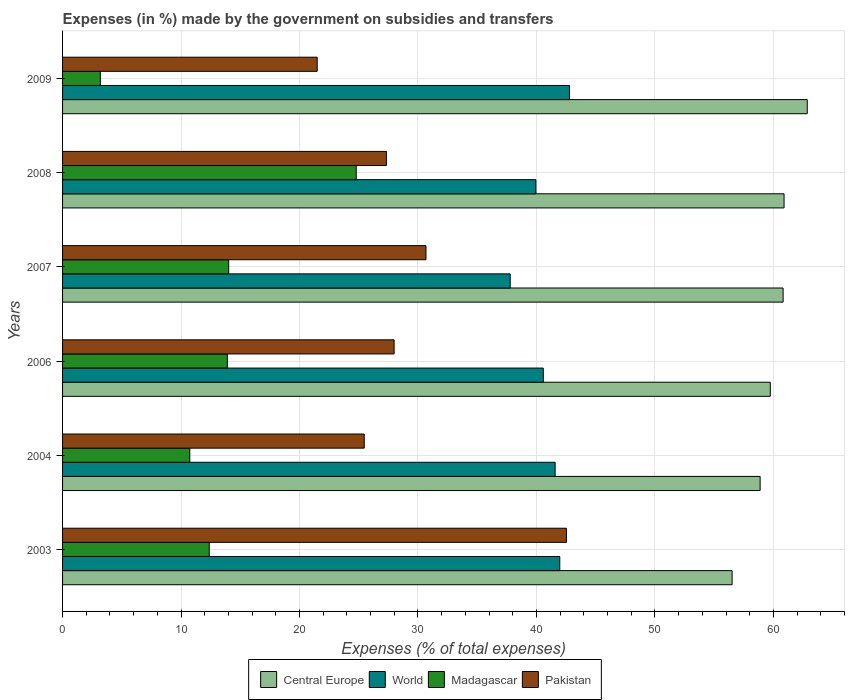How many groups of bars are there?
Your answer should be compact. 6. Are the number of bars per tick equal to the number of legend labels?
Your answer should be very brief. Yes. Are the number of bars on each tick of the Y-axis equal?
Your response must be concise. Yes. How many bars are there on the 2nd tick from the top?
Your answer should be compact. 4. How many bars are there on the 3rd tick from the bottom?
Ensure brevity in your answer.  4. In how many cases, is the number of bars for a given year not equal to the number of legend labels?
Your response must be concise. 0. What is the percentage of expenses made by the government on subsidies and transfers in Pakistan in 2003?
Make the answer very short. 42.53. Across all years, what is the maximum percentage of expenses made by the government on subsidies and transfers in Central Europe?
Provide a succinct answer. 62.86. Across all years, what is the minimum percentage of expenses made by the government on subsidies and transfers in World?
Provide a short and direct response. 37.79. What is the total percentage of expenses made by the government on subsidies and transfers in Pakistan in the graph?
Provide a short and direct response. 175.48. What is the difference between the percentage of expenses made by the government on subsidies and transfers in World in 2004 and that in 2008?
Your answer should be compact. 1.62. What is the difference between the percentage of expenses made by the government on subsidies and transfers in Madagascar in 2004 and the percentage of expenses made by the government on subsidies and transfers in Central Europe in 2008?
Ensure brevity in your answer.  -50.16. What is the average percentage of expenses made by the government on subsidies and transfers in Central Europe per year?
Give a very brief answer. 59.95. In the year 2009, what is the difference between the percentage of expenses made by the government on subsidies and transfers in Madagascar and percentage of expenses made by the government on subsidies and transfers in Pakistan?
Your response must be concise. -18.3. What is the ratio of the percentage of expenses made by the government on subsidies and transfers in Pakistan in 2006 to that in 2007?
Provide a short and direct response. 0.91. Is the percentage of expenses made by the government on subsidies and transfers in World in 2006 less than that in 2009?
Offer a very short reply. Yes. Is the difference between the percentage of expenses made by the government on subsidies and transfers in Madagascar in 2003 and 2009 greater than the difference between the percentage of expenses made by the government on subsidies and transfers in Pakistan in 2003 and 2009?
Keep it short and to the point. No. What is the difference between the highest and the second highest percentage of expenses made by the government on subsidies and transfers in Pakistan?
Your answer should be very brief. 11.86. What is the difference between the highest and the lowest percentage of expenses made by the government on subsidies and transfers in Central Europe?
Provide a short and direct response. 6.34. In how many years, is the percentage of expenses made by the government on subsidies and transfers in Pakistan greater than the average percentage of expenses made by the government on subsidies and transfers in Pakistan taken over all years?
Offer a terse response. 2. Is the sum of the percentage of expenses made by the government on subsidies and transfers in Pakistan in 2003 and 2009 greater than the maximum percentage of expenses made by the government on subsidies and transfers in Central Europe across all years?
Ensure brevity in your answer.  Yes. Is it the case that in every year, the sum of the percentage of expenses made by the government on subsidies and transfers in Madagascar and percentage of expenses made by the government on subsidies and transfers in Pakistan is greater than the sum of percentage of expenses made by the government on subsidies and transfers in Central Europe and percentage of expenses made by the government on subsidies and transfers in World?
Give a very brief answer. No. What does the 2nd bar from the top in 2009 represents?
Keep it short and to the point. Madagascar. Is it the case that in every year, the sum of the percentage of expenses made by the government on subsidies and transfers in Madagascar and percentage of expenses made by the government on subsidies and transfers in Central Europe is greater than the percentage of expenses made by the government on subsidies and transfers in Pakistan?
Your answer should be very brief. Yes. Are all the bars in the graph horizontal?
Your answer should be compact. Yes. How many years are there in the graph?
Give a very brief answer. 6. Are the values on the major ticks of X-axis written in scientific E-notation?
Provide a succinct answer. No. Does the graph contain any zero values?
Give a very brief answer. No. Does the graph contain grids?
Your answer should be compact. Yes. What is the title of the graph?
Provide a short and direct response. Expenses (in %) made by the government on subsidies and transfers. What is the label or title of the X-axis?
Make the answer very short. Expenses (% of total expenses). What is the label or title of the Y-axis?
Make the answer very short. Years. What is the Expenses (% of total expenses) of Central Europe in 2003?
Ensure brevity in your answer.  56.51. What is the Expenses (% of total expenses) of World in 2003?
Offer a very short reply. 41.97. What is the Expenses (% of total expenses) of Madagascar in 2003?
Offer a very short reply. 12.38. What is the Expenses (% of total expenses) of Pakistan in 2003?
Keep it short and to the point. 42.53. What is the Expenses (% of total expenses) of Central Europe in 2004?
Your answer should be compact. 58.88. What is the Expenses (% of total expenses) in World in 2004?
Keep it short and to the point. 41.58. What is the Expenses (% of total expenses) of Madagascar in 2004?
Your answer should be very brief. 10.74. What is the Expenses (% of total expenses) in Pakistan in 2004?
Make the answer very short. 25.46. What is the Expenses (% of total expenses) in Central Europe in 2006?
Your answer should be compact. 59.74. What is the Expenses (% of total expenses) of World in 2006?
Offer a very short reply. 40.58. What is the Expenses (% of total expenses) of Madagascar in 2006?
Your answer should be compact. 13.91. What is the Expenses (% of total expenses) of Pakistan in 2006?
Offer a terse response. 27.99. What is the Expenses (% of total expenses) of Central Europe in 2007?
Provide a succinct answer. 60.82. What is the Expenses (% of total expenses) in World in 2007?
Make the answer very short. 37.79. What is the Expenses (% of total expenses) of Madagascar in 2007?
Your answer should be very brief. 14.02. What is the Expenses (% of total expenses) of Pakistan in 2007?
Your response must be concise. 30.67. What is the Expenses (% of total expenses) of Central Europe in 2008?
Keep it short and to the point. 60.9. What is the Expenses (% of total expenses) of World in 2008?
Your answer should be very brief. 39.95. What is the Expenses (% of total expenses) of Madagascar in 2008?
Your response must be concise. 24.79. What is the Expenses (% of total expenses) in Pakistan in 2008?
Provide a succinct answer. 27.33. What is the Expenses (% of total expenses) of Central Europe in 2009?
Offer a very short reply. 62.86. What is the Expenses (% of total expenses) in World in 2009?
Provide a short and direct response. 42.79. What is the Expenses (% of total expenses) in Madagascar in 2009?
Provide a succinct answer. 3.19. What is the Expenses (% of total expenses) in Pakistan in 2009?
Your answer should be very brief. 21.49. Across all years, what is the maximum Expenses (% of total expenses) of Central Europe?
Your answer should be very brief. 62.86. Across all years, what is the maximum Expenses (% of total expenses) in World?
Make the answer very short. 42.79. Across all years, what is the maximum Expenses (% of total expenses) of Madagascar?
Offer a very short reply. 24.79. Across all years, what is the maximum Expenses (% of total expenses) in Pakistan?
Your answer should be compact. 42.53. Across all years, what is the minimum Expenses (% of total expenses) of Central Europe?
Keep it short and to the point. 56.51. Across all years, what is the minimum Expenses (% of total expenses) in World?
Your answer should be very brief. 37.79. Across all years, what is the minimum Expenses (% of total expenses) of Madagascar?
Make the answer very short. 3.19. Across all years, what is the minimum Expenses (% of total expenses) in Pakistan?
Your answer should be compact. 21.49. What is the total Expenses (% of total expenses) in Central Europe in the graph?
Your response must be concise. 359.71. What is the total Expenses (% of total expenses) in World in the graph?
Your answer should be compact. 244.65. What is the total Expenses (% of total expenses) of Madagascar in the graph?
Provide a succinct answer. 79.02. What is the total Expenses (% of total expenses) in Pakistan in the graph?
Ensure brevity in your answer.  175.48. What is the difference between the Expenses (% of total expenses) in Central Europe in 2003 and that in 2004?
Provide a succinct answer. -2.36. What is the difference between the Expenses (% of total expenses) in World in 2003 and that in 2004?
Your response must be concise. 0.39. What is the difference between the Expenses (% of total expenses) of Madagascar in 2003 and that in 2004?
Offer a terse response. 1.64. What is the difference between the Expenses (% of total expenses) of Pakistan in 2003 and that in 2004?
Provide a short and direct response. 17.07. What is the difference between the Expenses (% of total expenses) in Central Europe in 2003 and that in 2006?
Your response must be concise. -3.22. What is the difference between the Expenses (% of total expenses) of World in 2003 and that in 2006?
Offer a very short reply. 1.39. What is the difference between the Expenses (% of total expenses) of Madagascar in 2003 and that in 2006?
Make the answer very short. -1.53. What is the difference between the Expenses (% of total expenses) in Pakistan in 2003 and that in 2006?
Your answer should be very brief. 14.54. What is the difference between the Expenses (% of total expenses) of Central Europe in 2003 and that in 2007?
Make the answer very short. -4.31. What is the difference between the Expenses (% of total expenses) in World in 2003 and that in 2007?
Provide a short and direct response. 4.18. What is the difference between the Expenses (% of total expenses) in Madagascar in 2003 and that in 2007?
Your answer should be very brief. -1.64. What is the difference between the Expenses (% of total expenses) of Pakistan in 2003 and that in 2007?
Keep it short and to the point. 11.86. What is the difference between the Expenses (% of total expenses) of Central Europe in 2003 and that in 2008?
Give a very brief answer. -4.38. What is the difference between the Expenses (% of total expenses) of World in 2003 and that in 2008?
Provide a succinct answer. 2.02. What is the difference between the Expenses (% of total expenses) of Madagascar in 2003 and that in 2008?
Provide a succinct answer. -12.41. What is the difference between the Expenses (% of total expenses) of Pakistan in 2003 and that in 2008?
Give a very brief answer. 15.2. What is the difference between the Expenses (% of total expenses) of Central Europe in 2003 and that in 2009?
Provide a succinct answer. -6.34. What is the difference between the Expenses (% of total expenses) of World in 2003 and that in 2009?
Your response must be concise. -0.82. What is the difference between the Expenses (% of total expenses) in Madagascar in 2003 and that in 2009?
Offer a terse response. 9.19. What is the difference between the Expenses (% of total expenses) of Pakistan in 2003 and that in 2009?
Your answer should be very brief. 21.04. What is the difference between the Expenses (% of total expenses) of Central Europe in 2004 and that in 2006?
Your response must be concise. -0.86. What is the difference between the Expenses (% of total expenses) in Madagascar in 2004 and that in 2006?
Keep it short and to the point. -3.17. What is the difference between the Expenses (% of total expenses) of Pakistan in 2004 and that in 2006?
Ensure brevity in your answer.  -2.52. What is the difference between the Expenses (% of total expenses) in Central Europe in 2004 and that in 2007?
Offer a terse response. -1.94. What is the difference between the Expenses (% of total expenses) of World in 2004 and that in 2007?
Your answer should be compact. 3.79. What is the difference between the Expenses (% of total expenses) of Madagascar in 2004 and that in 2007?
Your answer should be very brief. -3.28. What is the difference between the Expenses (% of total expenses) in Pakistan in 2004 and that in 2007?
Provide a succinct answer. -5.21. What is the difference between the Expenses (% of total expenses) in Central Europe in 2004 and that in 2008?
Provide a succinct answer. -2.02. What is the difference between the Expenses (% of total expenses) of World in 2004 and that in 2008?
Offer a very short reply. 1.62. What is the difference between the Expenses (% of total expenses) in Madagascar in 2004 and that in 2008?
Ensure brevity in your answer.  -14.05. What is the difference between the Expenses (% of total expenses) in Pakistan in 2004 and that in 2008?
Offer a terse response. -1.87. What is the difference between the Expenses (% of total expenses) of Central Europe in 2004 and that in 2009?
Make the answer very short. -3.98. What is the difference between the Expenses (% of total expenses) in World in 2004 and that in 2009?
Offer a terse response. -1.22. What is the difference between the Expenses (% of total expenses) in Madagascar in 2004 and that in 2009?
Provide a short and direct response. 7.55. What is the difference between the Expenses (% of total expenses) of Pakistan in 2004 and that in 2009?
Give a very brief answer. 3.97. What is the difference between the Expenses (% of total expenses) in Central Europe in 2006 and that in 2007?
Provide a succinct answer. -1.08. What is the difference between the Expenses (% of total expenses) of World in 2006 and that in 2007?
Keep it short and to the point. 2.79. What is the difference between the Expenses (% of total expenses) in Madagascar in 2006 and that in 2007?
Keep it short and to the point. -0.11. What is the difference between the Expenses (% of total expenses) in Pakistan in 2006 and that in 2007?
Ensure brevity in your answer.  -2.69. What is the difference between the Expenses (% of total expenses) of Central Europe in 2006 and that in 2008?
Ensure brevity in your answer.  -1.16. What is the difference between the Expenses (% of total expenses) in World in 2006 and that in 2008?
Ensure brevity in your answer.  0.62. What is the difference between the Expenses (% of total expenses) of Madagascar in 2006 and that in 2008?
Your response must be concise. -10.88. What is the difference between the Expenses (% of total expenses) in Pakistan in 2006 and that in 2008?
Your answer should be very brief. 0.65. What is the difference between the Expenses (% of total expenses) in Central Europe in 2006 and that in 2009?
Give a very brief answer. -3.12. What is the difference between the Expenses (% of total expenses) in World in 2006 and that in 2009?
Ensure brevity in your answer.  -2.22. What is the difference between the Expenses (% of total expenses) in Madagascar in 2006 and that in 2009?
Keep it short and to the point. 10.72. What is the difference between the Expenses (% of total expenses) in Pakistan in 2006 and that in 2009?
Keep it short and to the point. 6.49. What is the difference between the Expenses (% of total expenses) of Central Europe in 2007 and that in 2008?
Your response must be concise. -0.08. What is the difference between the Expenses (% of total expenses) of World in 2007 and that in 2008?
Your answer should be compact. -2.17. What is the difference between the Expenses (% of total expenses) in Madagascar in 2007 and that in 2008?
Offer a terse response. -10.77. What is the difference between the Expenses (% of total expenses) of Pakistan in 2007 and that in 2008?
Your answer should be very brief. 3.34. What is the difference between the Expenses (% of total expenses) of Central Europe in 2007 and that in 2009?
Provide a short and direct response. -2.04. What is the difference between the Expenses (% of total expenses) of World in 2007 and that in 2009?
Provide a short and direct response. -5.01. What is the difference between the Expenses (% of total expenses) of Madagascar in 2007 and that in 2009?
Offer a terse response. 10.83. What is the difference between the Expenses (% of total expenses) of Pakistan in 2007 and that in 2009?
Give a very brief answer. 9.18. What is the difference between the Expenses (% of total expenses) of Central Europe in 2008 and that in 2009?
Your answer should be compact. -1.96. What is the difference between the Expenses (% of total expenses) in World in 2008 and that in 2009?
Provide a succinct answer. -2.84. What is the difference between the Expenses (% of total expenses) of Madagascar in 2008 and that in 2009?
Provide a short and direct response. 21.6. What is the difference between the Expenses (% of total expenses) in Pakistan in 2008 and that in 2009?
Provide a succinct answer. 5.84. What is the difference between the Expenses (% of total expenses) of Central Europe in 2003 and the Expenses (% of total expenses) of World in 2004?
Make the answer very short. 14.94. What is the difference between the Expenses (% of total expenses) in Central Europe in 2003 and the Expenses (% of total expenses) in Madagascar in 2004?
Give a very brief answer. 45.78. What is the difference between the Expenses (% of total expenses) of Central Europe in 2003 and the Expenses (% of total expenses) of Pakistan in 2004?
Offer a terse response. 31.05. What is the difference between the Expenses (% of total expenses) in World in 2003 and the Expenses (% of total expenses) in Madagascar in 2004?
Provide a succinct answer. 31.23. What is the difference between the Expenses (% of total expenses) of World in 2003 and the Expenses (% of total expenses) of Pakistan in 2004?
Keep it short and to the point. 16.51. What is the difference between the Expenses (% of total expenses) in Madagascar in 2003 and the Expenses (% of total expenses) in Pakistan in 2004?
Provide a succinct answer. -13.08. What is the difference between the Expenses (% of total expenses) of Central Europe in 2003 and the Expenses (% of total expenses) of World in 2006?
Provide a succinct answer. 15.94. What is the difference between the Expenses (% of total expenses) of Central Europe in 2003 and the Expenses (% of total expenses) of Madagascar in 2006?
Make the answer very short. 42.61. What is the difference between the Expenses (% of total expenses) in Central Europe in 2003 and the Expenses (% of total expenses) in Pakistan in 2006?
Give a very brief answer. 28.53. What is the difference between the Expenses (% of total expenses) of World in 2003 and the Expenses (% of total expenses) of Madagascar in 2006?
Give a very brief answer. 28.06. What is the difference between the Expenses (% of total expenses) of World in 2003 and the Expenses (% of total expenses) of Pakistan in 2006?
Your answer should be very brief. 13.98. What is the difference between the Expenses (% of total expenses) of Madagascar in 2003 and the Expenses (% of total expenses) of Pakistan in 2006?
Keep it short and to the point. -15.6. What is the difference between the Expenses (% of total expenses) in Central Europe in 2003 and the Expenses (% of total expenses) in World in 2007?
Give a very brief answer. 18.73. What is the difference between the Expenses (% of total expenses) in Central Europe in 2003 and the Expenses (% of total expenses) in Madagascar in 2007?
Ensure brevity in your answer.  42.49. What is the difference between the Expenses (% of total expenses) in Central Europe in 2003 and the Expenses (% of total expenses) in Pakistan in 2007?
Your answer should be very brief. 25.84. What is the difference between the Expenses (% of total expenses) in World in 2003 and the Expenses (% of total expenses) in Madagascar in 2007?
Provide a succinct answer. 27.95. What is the difference between the Expenses (% of total expenses) in World in 2003 and the Expenses (% of total expenses) in Pakistan in 2007?
Offer a very short reply. 11.29. What is the difference between the Expenses (% of total expenses) in Madagascar in 2003 and the Expenses (% of total expenses) in Pakistan in 2007?
Keep it short and to the point. -18.29. What is the difference between the Expenses (% of total expenses) in Central Europe in 2003 and the Expenses (% of total expenses) in World in 2008?
Provide a short and direct response. 16.56. What is the difference between the Expenses (% of total expenses) in Central Europe in 2003 and the Expenses (% of total expenses) in Madagascar in 2008?
Provide a short and direct response. 31.73. What is the difference between the Expenses (% of total expenses) of Central Europe in 2003 and the Expenses (% of total expenses) of Pakistan in 2008?
Offer a very short reply. 29.18. What is the difference between the Expenses (% of total expenses) of World in 2003 and the Expenses (% of total expenses) of Madagascar in 2008?
Provide a short and direct response. 17.18. What is the difference between the Expenses (% of total expenses) in World in 2003 and the Expenses (% of total expenses) in Pakistan in 2008?
Make the answer very short. 14.63. What is the difference between the Expenses (% of total expenses) in Madagascar in 2003 and the Expenses (% of total expenses) in Pakistan in 2008?
Your response must be concise. -14.95. What is the difference between the Expenses (% of total expenses) of Central Europe in 2003 and the Expenses (% of total expenses) of World in 2009?
Provide a succinct answer. 13.72. What is the difference between the Expenses (% of total expenses) of Central Europe in 2003 and the Expenses (% of total expenses) of Madagascar in 2009?
Your answer should be compact. 53.33. What is the difference between the Expenses (% of total expenses) in Central Europe in 2003 and the Expenses (% of total expenses) in Pakistan in 2009?
Offer a very short reply. 35.02. What is the difference between the Expenses (% of total expenses) of World in 2003 and the Expenses (% of total expenses) of Madagascar in 2009?
Provide a succinct answer. 38.78. What is the difference between the Expenses (% of total expenses) of World in 2003 and the Expenses (% of total expenses) of Pakistan in 2009?
Offer a very short reply. 20.48. What is the difference between the Expenses (% of total expenses) of Madagascar in 2003 and the Expenses (% of total expenses) of Pakistan in 2009?
Offer a terse response. -9.11. What is the difference between the Expenses (% of total expenses) of Central Europe in 2004 and the Expenses (% of total expenses) of World in 2006?
Your answer should be very brief. 18.3. What is the difference between the Expenses (% of total expenses) of Central Europe in 2004 and the Expenses (% of total expenses) of Madagascar in 2006?
Keep it short and to the point. 44.97. What is the difference between the Expenses (% of total expenses) of Central Europe in 2004 and the Expenses (% of total expenses) of Pakistan in 2006?
Provide a short and direct response. 30.89. What is the difference between the Expenses (% of total expenses) of World in 2004 and the Expenses (% of total expenses) of Madagascar in 2006?
Your answer should be compact. 27.67. What is the difference between the Expenses (% of total expenses) of World in 2004 and the Expenses (% of total expenses) of Pakistan in 2006?
Ensure brevity in your answer.  13.59. What is the difference between the Expenses (% of total expenses) of Madagascar in 2004 and the Expenses (% of total expenses) of Pakistan in 2006?
Your answer should be very brief. -17.25. What is the difference between the Expenses (% of total expenses) in Central Europe in 2004 and the Expenses (% of total expenses) in World in 2007?
Offer a very short reply. 21.09. What is the difference between the Expenses (% of total expenses) in Central Europe in 2004 and the Expenses (% of total expenses) in Madagascar in 2007?
Offer a terse response. 44.86. What is the difference between the Expenses (% of total expenses) of Central Europe in 2004 and the Expenses (% of total expenses) of Pakistan in 2007?
Your answer should be compact. 28.2. What is the difference between the Expenses (% of total expenses) in World in 2004 and the Expenses (% of total expenses) in Madagascar in 2007?
Ensure brevity in your answer.  27.56. What is the difference between the Expenses (% of total expenses) in World in 2004 and the Expenses (% of total expenses) in Pakistan in 2007?
Your answer should be compact. 10.9. What is the difference between the Expenses (% of total expenses) in Madagascar in 2004 and the Expenses (% of total expenses) in Pakistan in 2007?
Keep it short and to the point. -19.94. What is the difference between the Expenses (% of total expenses) in Central Europe in 2004 and the Expenses (% of total expenses) in World in 2008?
Provide a short and direct response. 18.93. What is the difference between the Expenses (% of total expenses) in Central Europe in 2004 and the Expenses (% of total expenses) in Madagascar in 2008?
Your response must be concise. 34.09. What is the difference between the Expenses (% of total expenses) in Central Europe in 2004 and the Expenses (% of total expenses) in Pakistan in 2008?
Provide a succinct answer. 31.54. What is the difference between the Expenses (% of total expenses) in World in 2004 and the Expenses (% of total expenses) in Madagascar in 2008?
Give a very brief answer. 16.79. What is the difference between the Expenses (% of total expenses) of World in 2004 and the Expenses (% of total expenses) of Pakistan in 2008?
Your answer should be compact. 14.24. What is the difference between the Expenses (% of total expenses) in Madagascar in 2004 and the Expenses (% of total expenses) in Pakistan in 2008?
Your answer should be compact. -16.6. What is the difference between the Expenses (% of total expenses) of Central Europe in 2004 and the Expenses (% of total expenses) of World in 2009?
Give a very brief answer. 16.09. What is the difference between the Expenses (% of total expenses) of Central Europe in 2004 and the Expenses (% of total expenses) of Madagascar in 2009?
Your answer should be compact. 55.69. What is the difference between the Expenses (% of total expenses) of Central Europe in 2004 and the Expenses (% of total expenses) of Pakistan in 2009?
Ensure brevity in your answer.  37.39. What is the difference between the Expenses (% of total expenses) in World in 2004 and the Expenses (% of total expenses) in Madagascar in 2009?
Offer a terse response. 38.39. What is the difference between the Expenses (% of total expenses) of World in 2004 and the Expenses (% of total expenses) of Pakistan in 2009?
Provide a short and direct response. 20.08. What is the difference between the Expenses (% of total expenses) of Madagascar in 2004 and the Expenses (% of total expenses) of Pakistan in 2009?
Offer a terse response. -10.76. What is the difference between the Expenses (% of total expenses) in Central Europe in 2006 and the Expenses (% of total expenses) in World in 2007?
Your answer should be very brief. 21.95. What is the difference between the Expenses (% of total expenses) in Central Europe in 2006 and the Expenses (% of total expenses) in Madagascar in 2007?
Provide a succinct answer. 45.71. What is the difference between the Expenses (% of total expenses) of Central Europe in 2006 and the Expenses (% of total expenses) of Pakistan in 2007?
Your answer should be very brief. 29.06. What is the difference between the Expenses (% of total expenses) in World in 2006 and the Expenses (% of total expenses) in Madagascar in 2007?
Provide a short and direct response. 26.56. What is the difference between the Expenses (% of total expenses) in World in 2006 and the Expenses (% of total expenses) in Pakistan in 2007?
Your answer should be very brief. 9.9. What is the difference between the Expenses (% of total expenses) in Madagascar in 2006 and the Expenses (% of total expenses) in Pakistan in 2007?
Keep it short and to the point. -16.77. What is the difference between the Expenses (% of total expenses) of Central Europe in 2006 and the Expenses (% of total expenses) of World in 2008?
Make the answer very short. 19.78. What is the difference between the Expenses (% of total expenses) in Central Europe in 2006 and the Expenses (% of total expenses) in Madagascar in 2008?
Ensure brevity in your answer.  34.95. What is the difference between the Expenses (% of total expenses) of Central Europe in 2006 and the Expenses (% of total expenses) of Pakistan in 2008?
Your response must be concise. 32.4. What is the difference between the Expenses (% of total expenses) in World in 2006 and the Expenses (% of total expenses) in Madagascar in 2008?
Your response must be concise. 15.79. What is the difference between the Expenses (% of total expenses) in World in 2006 and the Expenses (% of total expenses) in Pakistan in 2008?
Your answer should be compact. 13.24. What is the difference between the Expenses (% of total expenses) in Madagascar in 2006 and the Expenses (% of total expenses) in Pakistan in 2008?
Make the answer very short. -13.43. What is the difference between the Expenses (% of total expenses) of Central Europe in 2006 and the Expenses (% of total expenses) of World in 2009?
Ensure brevity in your answer.  16.94. What is the difference between the Expenses (% of total expenses) of Central Europe in 2006 and the Expenses (% of total expenses) of Madagascar in 2009?
Give a very brief answer. 56.55. What is the difference between the Expenses (% of total expenses) in Central Europe in 2006 and the Expenses (% of total expenses) in Pakistan in 2009?
Your answer should be compact. 38.24. What is the difference between the Expenses (% of total expenses) of World in 2006 and the Expenses (% of total expenses) of Madagascar in 2009?
Your answer should be very brief. 37.39. What is the difference between the Expenses (% of total expenses) in World in 2006 and the Expenses (% of total expenses) in Pakistan in 2009?
Your answer should be very brief. 19.08. What is the difference between the Expenses (% of total expenses) in Madagascar in 2006 and the Expenses (% of total expenses) in Pakistan in 2009?
Your response must be concise. -7.58. What is the difference between the Expenses (% of total expenses) in Central Europe in 2007 and the Expenses (% of total expenses) in World in 2008?
Your answer should be very brief. 20.87. What is the difference between the Expenses (% of total expenses) of Central Europe in 2007 and the Expenses (% of total expenses) of Madagascar in 2008?
Provide a succinct answer. 36.03. What is the difference between the Expenses (% of total expenses) in Central Europe in 2007 and the Expenses (% of total expenses) in Pakistan in 2008?
Provide a succinct answer. 33.49. What is the difference between the Expenses (% of total expenses) of World in 2007 and the Expenses (% of total expenses) of Madagascar in 2008?
Your answer should be compact. 13. What is the difference between the Expenses (% of total expenses) of World in 2007 and the Expenses (% of total expenses) of Pakistan in 2008?
Offer a terse response. 10.45. What is the difference between the Expenses (% of total expenses) in Madagascar in 2007 and the Expenses (% of total expenses) in Pakistan in 2008?
Your answer should be very brief. -13.31. What is the difference between the Expenses (% of total expenses) in Central Europe in 2007 and the Expenses (% of total expenses) in World in 2009?
Keep it short and to the point. 18.03. What is the difference between the Expenses (% of total expenses) of Central Europe in 2007 and the Expenses (% of total expenses) of Madagascar in 2009?
Give a very brief answer. 57.63. What is the difference between the Expenses (% of total expenses) in Central Europe in 2007 and the Expenses (% of total expenses) in Pakistan in 2009?
Ensure brevity in your answer.  39.33. What is the difference between the Expenses (% of total expenses) of World in 2007 and the Expenses (% of total expenses) of Madagascar in 2009?
Keep it short and to the point. 34.6. What is the difference between the Expenses (% of total expenses) of World in 2007 and the Expenses (% of total expenses) of Pakistan in 2009?
Your response must be concise. 16.29. What is the difference between the Expenses (% of total expenses) of Madagascar in 2007 and the Expenses (% of total expenses) of Pakistan in 2009?
Offer a terse response. -7.47. What is the difference between the Expenses (% of total expenses) in Central Europe in 2008 and the Expenses (% of total expenses) in World in 2009?
Provide a short and direct response. 18.11. What is the difference between the Expenses (% of total expenses) in Central Europe in 2008 and the Expenses (% of total expenses) in Madagascar in 2009?
Provide a succinct answer. 57.71. What is the difference between the Expenses (% of total expenses) in Central Europe in 2008 and the Expenses (% of total expenses) in Pakistan in 2009?
Provide a short and direct response. 39.41. What is the difference between the Expenses (% of total expenses) in World in 2008 and the Expenses (% of total expenses) in Madagascar in 2009?
Your response must be concise. 36.76. What is the difference between the Expenses (% of total expenses) of World in 2008 and the Expenses (% of total expenses) of Pakistan in 2009?
Your answer should be very brief. 18.46. What is the difference between the Expenses (% of total expenses) in Madagascar in 2008 and the Expenses (% of total expenses) in Pakistan in 2009?
Give a very brief answer. 3.29. What is the average Expenses (% of total expenses) in Central Europe per year?
Make the answer very short. 59.95. What is the average Expenses (% of total expenses) in World per year?
Keep it short and to the point. 40.78. What is the average Expenses (% of total expenses) of Madagascar per year?
Give a very brief answer. 13.17. What is the average Expenses (% of total expenses) in Pakistan per year?
Provide a short and direct response. 29.25. In the year 2003, what is the difference between the Expenses (% of total expenses) of Central Europe and Expenses (% of total expenses) of World?
Offer a very short reply. 14.55. In the year 2003, what is the difference between the Expenses (% of total expenses) of Central Europe and Expenses (% of total expenses) of Madagascar?
Your answer should be compact. 44.13. In the year 2003, what is the difference between the Expenses (% of total expenses) of Central Europe and Expenses (% of total expenses) of Pakistan?
Provide a short and direct response. 13.98. In the year 2003, what is the difference between the Expenses (% of total expenses) of World and Expenses (% of total expenses) of Madagascar?
Provide a succinct answer. 29.59. In the year 2003, what is the difference between the Expenses (% of total expenses) of World and Expenses (% of total expenses) of Pakistan?
Ensure brevity in your answer.  -0.56. In the year 2003, what is the difference between the Expenses (% of total expenses) in Madagascar and Expenses (% of total expenses) in Pakistan?
Provide a short and direct response. -30.15. In the year 2004, what is the difference between the Expenses (% of total expenses) of Central Europe and Expenses (% of total expenses) of World?
Give a very brief answer. 17.3. In the year 2004, what is the difference between the Expenses (% of total expenses) in Central Europe and Expenses (% of total expenses) in Madagascar?
Give a very brief answer. 48.14. In the year 2004, what is the difference between the Expenses (% of total expenses) in Central Europe and Expenses (% of total expenses) in Pakistan?
Keep it short and to the point. 33.42. In the year 2004, what is the difference between the Expenses (% of total expenses) of World and Expenses (% of total expenses) of Madagascar?
Keep it short and to the point. 30.84. In the year 2004, what is the difference between the Expenses (% of total expenses) in World and Expenses (% of total expenses) in Pakistan?
Offer a terse response. 16.11. In the year 2004, what is the difference between the Expenses (% of total expenses) in Madagascar and Expenses (% of total expenses) in Pakistan?
Offer a terse response. -14.73. In the year 2006, what is the difference between the Expenses (% of total expenses) in Central Europe and Expenses (% of total expenses) in World?
Provide a short and direct response. 19.16. In the year 2006, what is the difference between the Expenses (% of total expenses) in Central Europe and Expenses (% of total expenses) in Madagascar?
Your answer should be very brief. 45.83. In the year 2006, what is the difference between the Expenses (% of total expenses) of Central Europe and Expenses (% of total expenses) of Pakistan?
Offer a terse response. 31.75. In the year 2006, what is the difference between the Expenses (% of total expenses) in World and Expenses (% of total expenses) in Madagascar?
Your answer should be very brief. 26.67. In the year 2006, what is the difference between the Expenses (% of total expenses) in World and Expenses (% of total expenses) in Pakistan?
Keep it short and to the point. 12.59. In the year 2006, what is the difference between the Expenses (% of total expenses) of Madagascar and Expenses (% of total expenses) of Pakistan?
Your answer should be compact. -14.08. In the year 2007, what is the difference between the Expenses (% of total expenses) of Central Europe and Expenses (% of total expenses) of World?
Ensure brevity in your answer.  23.03. In the year 2007, what is the difference between the Expenses (% of total expenses) of Central Europe and Expenses (% of total expenses) of Madagascar?
Offer a very short reply. 46.8. In the year 2007, what is the difference between the Expenses (% of total expenses) of Central Europe and Expenses (% of total expenses) of Pakistan?
Your answer should be compact. 30.15. In the year 2007, what is the difference between the Expenses (% of total expenses) of World and Expenses (% of total expenses) of Madagascar?
Ensure brevity in your answer.  23.76. In the year 2007, what is the difference between the Expenses (% of total expenses) of World and Expenses (% of total expenses) of Pakistan?
Offer a terse response. 7.11. In the year 2007, what is the difference between the Expenses (% of total expenses) in Madagascar and Expenses (% of total expenses) in Pakistan?
Ensure brevity in your answer.  -16.65. In the year 2008, what is the difference between the Expenses (% of total expenses) of Central Europe and Expenses (% of total expenses) of World?
Your answer should be very brief. 20.95. In the year 2008, what is the difference between the Expenses (% of total expenses) in Central Europe and Expenses (% of total expenses) in Madagascar?
Your answer should be compact. 36.11. In the year 2008, what is the difference between the Expenses (% of total expenses) of Central Europe and Expenses (% of total expenses) of Pakistan?
Your answer should be compact. 33.56. In the year 2008, what is the difference between the Expenses (% of total expenses) of World and Expenses (% of total expenses) of Madagascar?
Your response must be concise. 15.17. In the year 2008, what is the difference between the Expenses (% of total expenses) in World and Expenses (% of total expenses) in Pakistan?
Your response must be concise. 12.62. In the year 2008, what is the difference between the Expenses (% of total expenses) of Madagascar and Expenses (% of total expenses) of Pakistan?
Provide a succinct answer. -2.55. In the year 2009, what is the difference between the Expenses (% of total expenses) of Central Europe and Expenses (% of total expenses) of World?
Give a very brief answer. 20.07. In the year 2009, what is the difference between the Expenses (% of total expenses) in Central Europe and Expenses (% of total expenses) in Madagascar?
Your answer should be very brief. 59.67. In the year 2009, what is the difference between the Expenses (% of total expenses) in Central Europe and Expenses (% of total expenses) in Pakistan?
Your answer should be compact. 41.36. In the year 2009, what is the difference between the Expenses (% of total expenses) in World and Expenses (% of total expenses) in Madagascar?
Your response must be concise. 39.6. In the year 2009, what is the difference between the Expenses (% of total expenses) of World and Expenses (% of total expenses) of Pakistan?
Give a very brief answer. 21.3. In the year 2009, what is the difference between the Expenses (% of total expenses) of Madagascar and Expenses (% of total expenses) of Pakistan?
Provide a succinct answer. -18.3. What is the ratio of the Expenses (% of total expenses) in Central Europe in 2003 to that in 2004?
Make the answer very short. 0.96. What is the ratio of the Expenses (% of total expenses) in World in 2003 to that in 2004?
Keep it short and to the point. 1.01. What is the ratio of the Expenses (% of total expenses) of Madagascar in 2003 to that in 2004?
Ensure brevity in your answer.  1.15. What is the ratio of the Expenses (% of total expenses) of Pakistan in 2003 to that in 2004?
Provide a succinct answer. 1.67. What is the ratio of the Expenses (% of total expenses) of Central Europe in 2003 to that in 2006?
Offer a very short reply. 0.95. What is the ratio of the Expenses (% of total expenses) of World in 2003 to that in 2006?
Offer a very short reply. 1.03. What is the ratio of the Expenses (% of total expenses) in Madagascar in 2003 to that in 2006?
Ensure brevity in your answer.  0.89. What is the ratio of the Expenses (% of total expenses) in Pakistan in 2003 to that in 2006?
Provide a succinct answer. 1.52. What is the ratio of the Expenses (% of total expenses) of Central Europe in 2003 to that in 2007?
Offer a terse response. 0.93. What is the ratio of the Expenses (% of total expenses) in World in 2003 to that in 2007?
Your answer should be compact. 1.11. What is the ratio of the Expenses (% of total expenses) in Madagascar in 2003 to that in 2007?
Provide a succinct answer. 0.88. What is the ratio of the Expenses (% of total expenses) of Pakistan in 2003 to that in 2007?
Your answer should be very brief. 1.39. What is the ratio of the Expenses (% of total expenses) of Central Europe in 2003 to that in 2008?
Offer a terse response. 0.93. What is the ratio of the Expenses (% of total expenses) in World in 2003 to that in 2008?
Provide a succinct answer. 1.05. What is the ratio of the Expenses (% of total expenses) of Madagascar in 2003 to that in 2008?
Make the answer very short. 0.5. What is the ratio of the Expenses (% of total expenses) in Pakistan in 2003 to that in 2008?
Your response must be concise. 1.56. What is the ratio of the Expenses (% of total expenses) in Central Europe in 2003 to that in 2009?
Provide a short and direct response. 0.9. What is the ratio of the Expenses (% of total expenses) in World in 2003 to that in 2009?
Provide a succinct answer. 0.98. What is the ratio of the Expenses (% of total expenses) in Madagascar in 2003 to that in 2009?
Provide a short and direct response. 3.88. What is the ratio of the Expenses (% of total expenses) in Pakistan in 2003 to that in 2009?
Your answer should be very brief. 1.98. What is the ratio of the Expenses (% of total expenses) of Central Europe in 2004 to that in 2006?
Keep it short and to the point. 0.99. What is the ratio of the Expenses (% of total expenses) of World in 2004 to that in 2006?
Keep it short and to the point. 1.02. What is the ratio of the Expenses (% of total expenses) of Madagascar in 2004 to that in 2006?
Your answer should be very brief. 0.77. What is the ratio of the Expenses (% of total expenses) of Pakistan in 2004 to that in 2006?
Ensure brevity in your answer.  0.91. What is the ratio of the Expenses (% of total expenses) in Central Europe in 2004 to that in 2007?
Offer a very short reply. 0.97. What is the ratio of the Expenses (% of total expenses) in World in 2004 to that in 2007?
Ensure brevity in your answer.  1.1. What is the ratio of the Expenses (% of total expenses) of Madagascar in 2004 to that in 2007?
Make the answer very short. 0.77. What is the ratio of the Expenses (% of total expenses) of Pakistan in 2004 to that in 2007?
Provide a succinct answer. 0.83. What is the ratio of the Expenses (% of total expenses) in Central Europe in 2004 to that in 2008?
Offer a terse response. 0.97. What is the ratio of the Expenses (% of total expenses) in World in 2004 to that in 2008?
Your answer should be compact. 1.04. What is the ratio of the Expenses (% of total expenses) in Madagascar in 2004 to that in 2008?
Make the answer very short. 0.43. What is the ratio of the Expenses (% of total expenses) of Pakistan in 2004 to that in 2008?
Make the answer very short. 0.93. What is the ratio of the Expenses (% of total expenses) in Central Europe in 2004 to that in 2009?
Offer a very short reply. 0.94. What is the ratio of the Expenses (% of total expenses) in World in 2004 to that in 2009?
Offer a very short reply. 0.97. What is the ratio of the Expenses (% of total expenses) of Madagascar in 2004 to that in 2009?
Your response must be concise. 3.37. What is the ratio of the Expenses (% of total expenses) in Pakistan in 2004 to that in 2009?
Give a very brief answer. 1.18. What is the ratio of the Expenses (% of total expenses) in Central Europe in 2006 to that in 2007?
Provide a short and direct response. 0.98. What is the ratio of the Expenses (% of total expenses) of World in 2006 to that in 2007?
Offer a very short reply. 1.07. What is the ratio of the Expenses (% of total expenses) of Madagascar in 2006 to that in 2007?
Your answer should be compact. 0.99. What is the ratio of the Expenses (% of total expenses) in Pakistan in 2006 to that in 2007?
Give a very brief answer. 0.91. What is the ratio of the Expenses (% of total expenses) of Central Europe in 2006 to that in 2008?
Give a very brief answer. 0.98. What is the ratio of the Expenses (% of total expenses) in World in 2006 to that in 2008?
Your answer should be compact. 1.02. What is the ratio of the Expenses (% of total expenses) of Madagascar in 2006 to that in 2008?
Make the answer very short. 0.56. What is the ratio of the Expenses (% of total expenses) of Pakistan in 2006 to that in 2008?
Make the answer very short. 1.02. What is the ratio of the Expenses (% of total expenses) of Central Europe in 2006 to that in 2009?
Your answer should be compact. 0.95. What is the ratio of the Expenses (% of total expenses) of World in 2006 to that in 2009?
Give a very brief answer. 0.95. What is the ratio of the Expenses (% of total expenses) in Madagascar in 2006 to that in 2009?
Provide a succinct answer. 4.36. What is the ratio of the Expenses (% of total expenses) of Pakistan in 2006 to that in 2009?
Offer a very short reply. 1.3. What is the ratio of the Expenses (% of total expenses) in Central Europe in 2007 to that in 2008?
Offer a terse response. 1. What is the ratio of the Expenses (% of total expenses) in World in 2007 to that in 2008?
Keep it short and to the point. 0.95. What is the ratio of the Expenses (% of total expenses) of Madagascar in 2007 to that in 2008?
Give a very brief answer. 0.57. What is the ratio of the Expenses (% of total expenses) in Pakistan in 2007 to that in 2008?
Your answer should be very brief. 1.12. What is the ratio of the Expenses (% of total expenses) in Central Europe in 2007 to that in 2009?
Your response must be concise. 0.97. What is the ratio of the Expenses (% of total expenses) of World in 2007 to that in 2009?
Provide a short and direct response. 0.88. What is the ratio of the Expenses (% of total expenses) in Madagascar in 2007 to that in 2009?
Make the answer very short. 4.4. What is the ratio of the Expenses (% of total expenses) in Pakistan in 2007 to that in 2009?
Offer a terse response. 1.43. What is the ratio of the Expenses (% of total expenses) in Central Europe in 2008 to that in 2009?
Give a very brief answer. 0.97. What is the ratio of the Expenses (% of total expenses) in World in 2008 to that in 2009?
Offer a very short reply. 0.93. What is the ratio of the Expenses (% of total expenses) of Madagascar in 2008 to that in 2009?
Ensure brevity in your answer.  7.77. What is the ratio of the Expenses (% of total expenses) in Pakistan in 2008 to that in 2009?
Provide a short and direct response. 1.27. What is the difference between the highest and the second highest Expenses (% of total expenses) of Central Europe?
Offer a very short reply. 1.96. What is the difference between the highest and the second highest Expenses (% of total expenses) of World?
Offer a terse response. 0.82. What is the difference between the highest and the second highest Expenses (% of total expenses) of Madagascar?
Ensure brevity in your answer.  10.77. What is the difference between the highest and the second highest Expenses (% of total expenses) in Pakistan?
Ensure brevity in your answer.  11.86. What is the difference between the highest and the lowest Expenses (% of total expenses) in Central Europe?
Give a very brief answer. 6.34. What is the difference between the highest and the lowest Expenses (% of total expenses) of World?
Your answer should be very brief. 5.01. What is the difference between the highest and the lowest Expenses (% of total expenses) of Madagascar?
Offer a very short reply. 21.6. What is the difference between the highest and the lowest Expenses (% of total expenses) in Pakistan?
Make the answer very short. 21.04. 